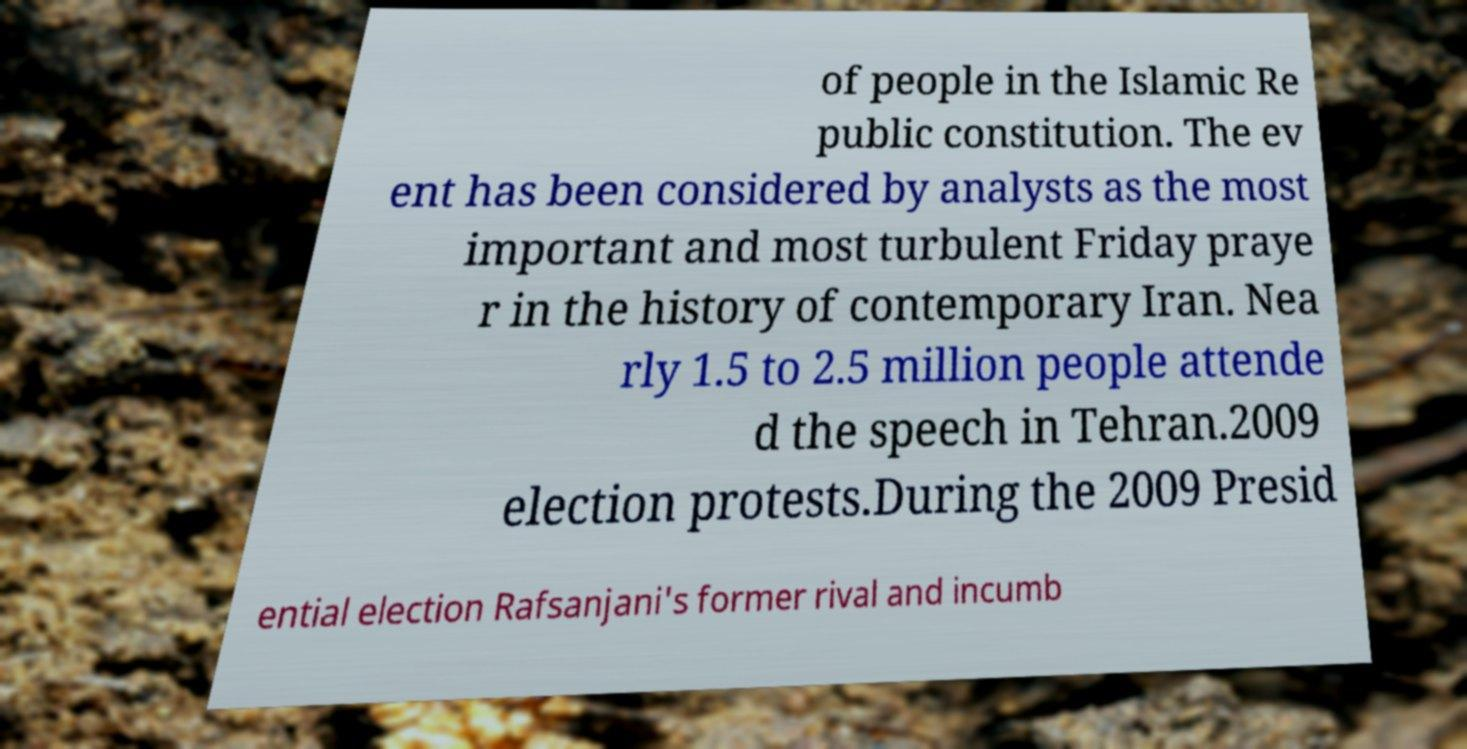Can you accurately transcribe the text from the provided image for me? of people in the Islamic Re public constitution. The ev ent has been considered by analysts as the most important and most turbulent Friday praye r in the history of contemporary Iran. Nea rly 1.5 to 2.5 million people attende d the speech in Tehran.2009 election protests.During the 2009 Presid ential election Rafsanjani's former rival and incumb 